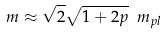<formula> <loc_0><loc_0><loc_500><loc_500>m \approx \sqrt { 2 } \sqrt { 1 + 2 p } \ m _ { p l }</formula> 